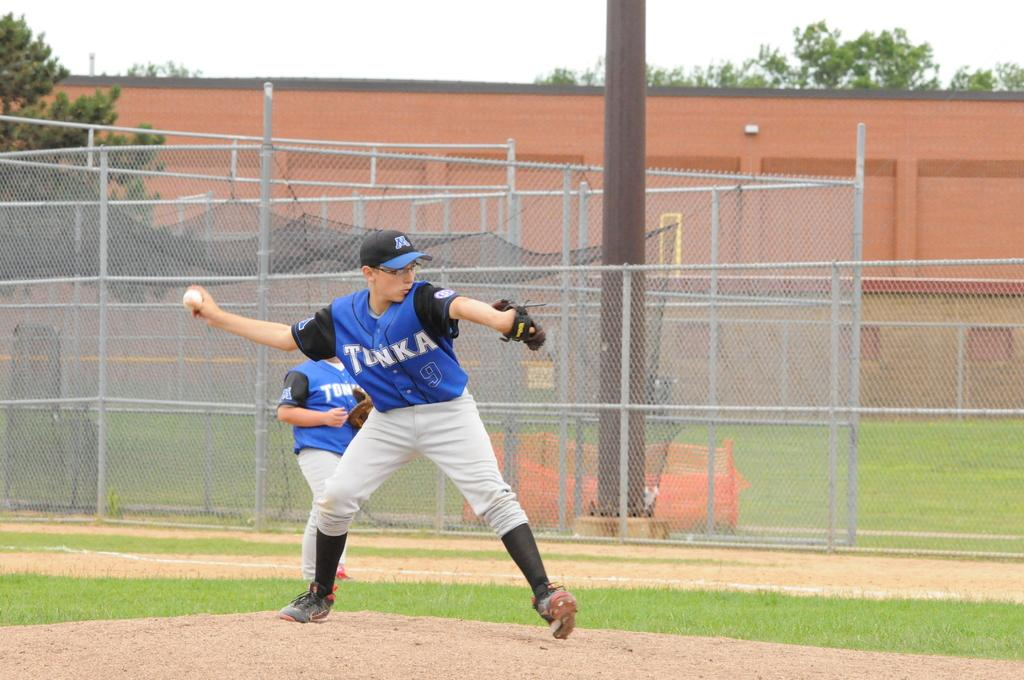<image>
Give a short and clear explanation of the subsequent image. A boys baseball game from the view of the pitcher who is wearing a Tonka jersey. 